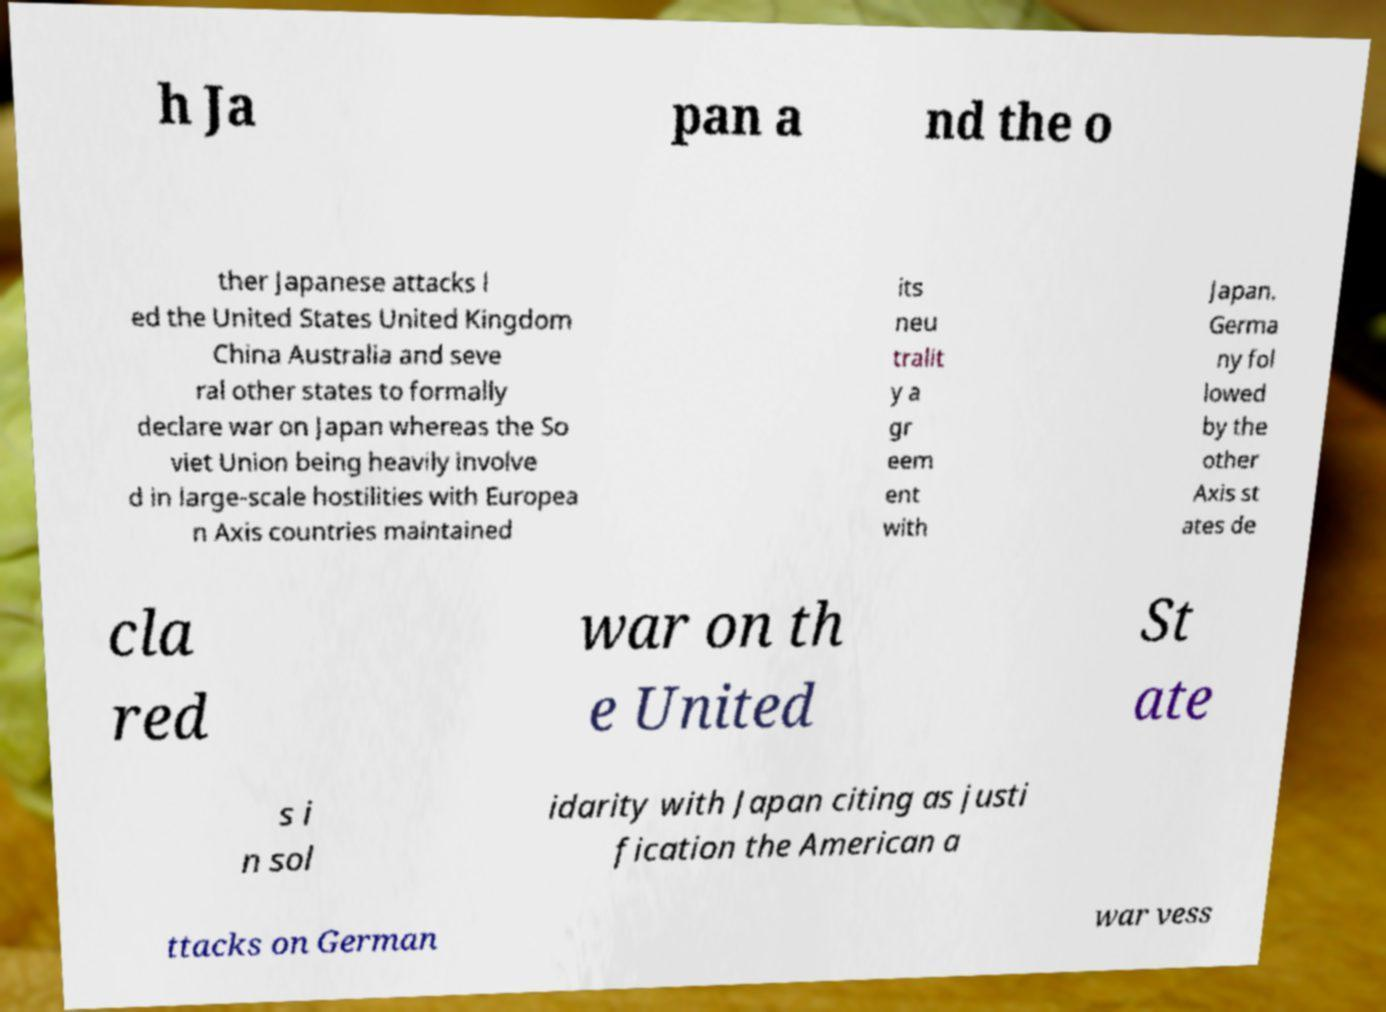Can you accurately transcribe the text from the provided image for me? h Ja pan a nd the o ther Japanese attacks l ed the United States United Kingdom China Australia and seve ral other states to formally declare war on Japan whereas the So viet Union being heavily involve d in large-scale hostilities with Europea n Axis countries maintained its neu tralit y a gr eem ent with Japan. Germa ny fol lowed by the other Axis st ates de cla red war on th e United St ate s i n sol idarity with Japan citing as justi fication the American a ttacks on German war vess 